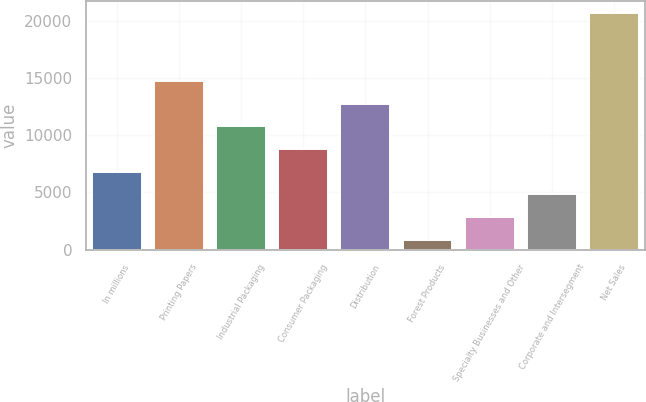<chart> <loc_0><loc_0><loc_500><loc_500><bar_chart><fcel>In millions<fcel>Printing Papers<fcel>Industrial Packaging<fcel>Consumer Packaging<fcel>Distribution<fcel>Forest Products<fcel>Specialty Businesses and Other<fcel>Corporate and Intersegment<fcel>Net Sales<nl><fcel>6828.8<fcel>14767.2<fcel>10798<fcel>8813.4<fcel>12782.6<fcel>875<fcel>2859.6<fcel>4844.2<fcel>20721<nl></chart> 